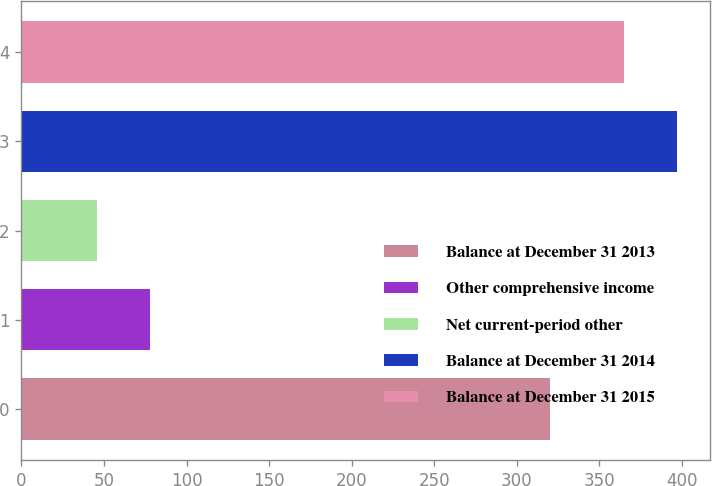<chart> <loc_0><loc_0><loc_500><loc_500><bar_chart><fcel>Balance at December 31 2013<fcel>Other comprehensive income<fcel>Net current-period other<fcel>Balance at December 31 2014<fcel>Balance at December 31 2015<nl><fcel>320<fcel>78<fcel>46<fcel>397<fcel>365<nl></chart> 